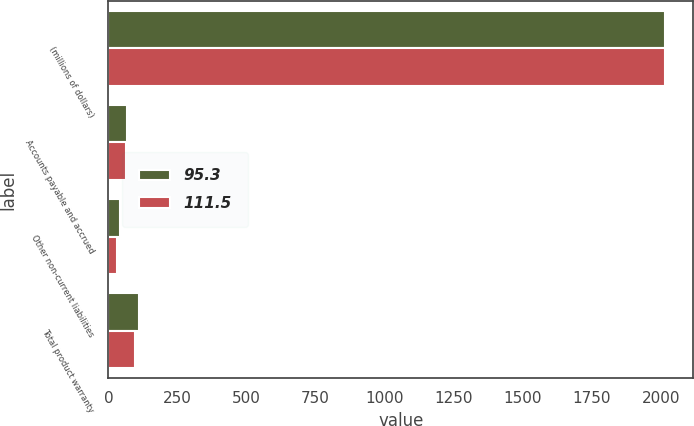<chart> <loc_0><loc_0><loc_500><loc_500><stacked_bar_chart><ecel><fcel>(millions of dollars)<fcel>Accounts payable and accrued<fcel>Other non-current liabilities<fcel>Total product warranty<nl><fcel>95.3<fcel>2017<fcel>69<fcel>42.5<fcel>111.5<nl><fcel>111.5<fcel>2016<fcel>63.9<fcel>31.4<fcel>95.3<nl></chart> 